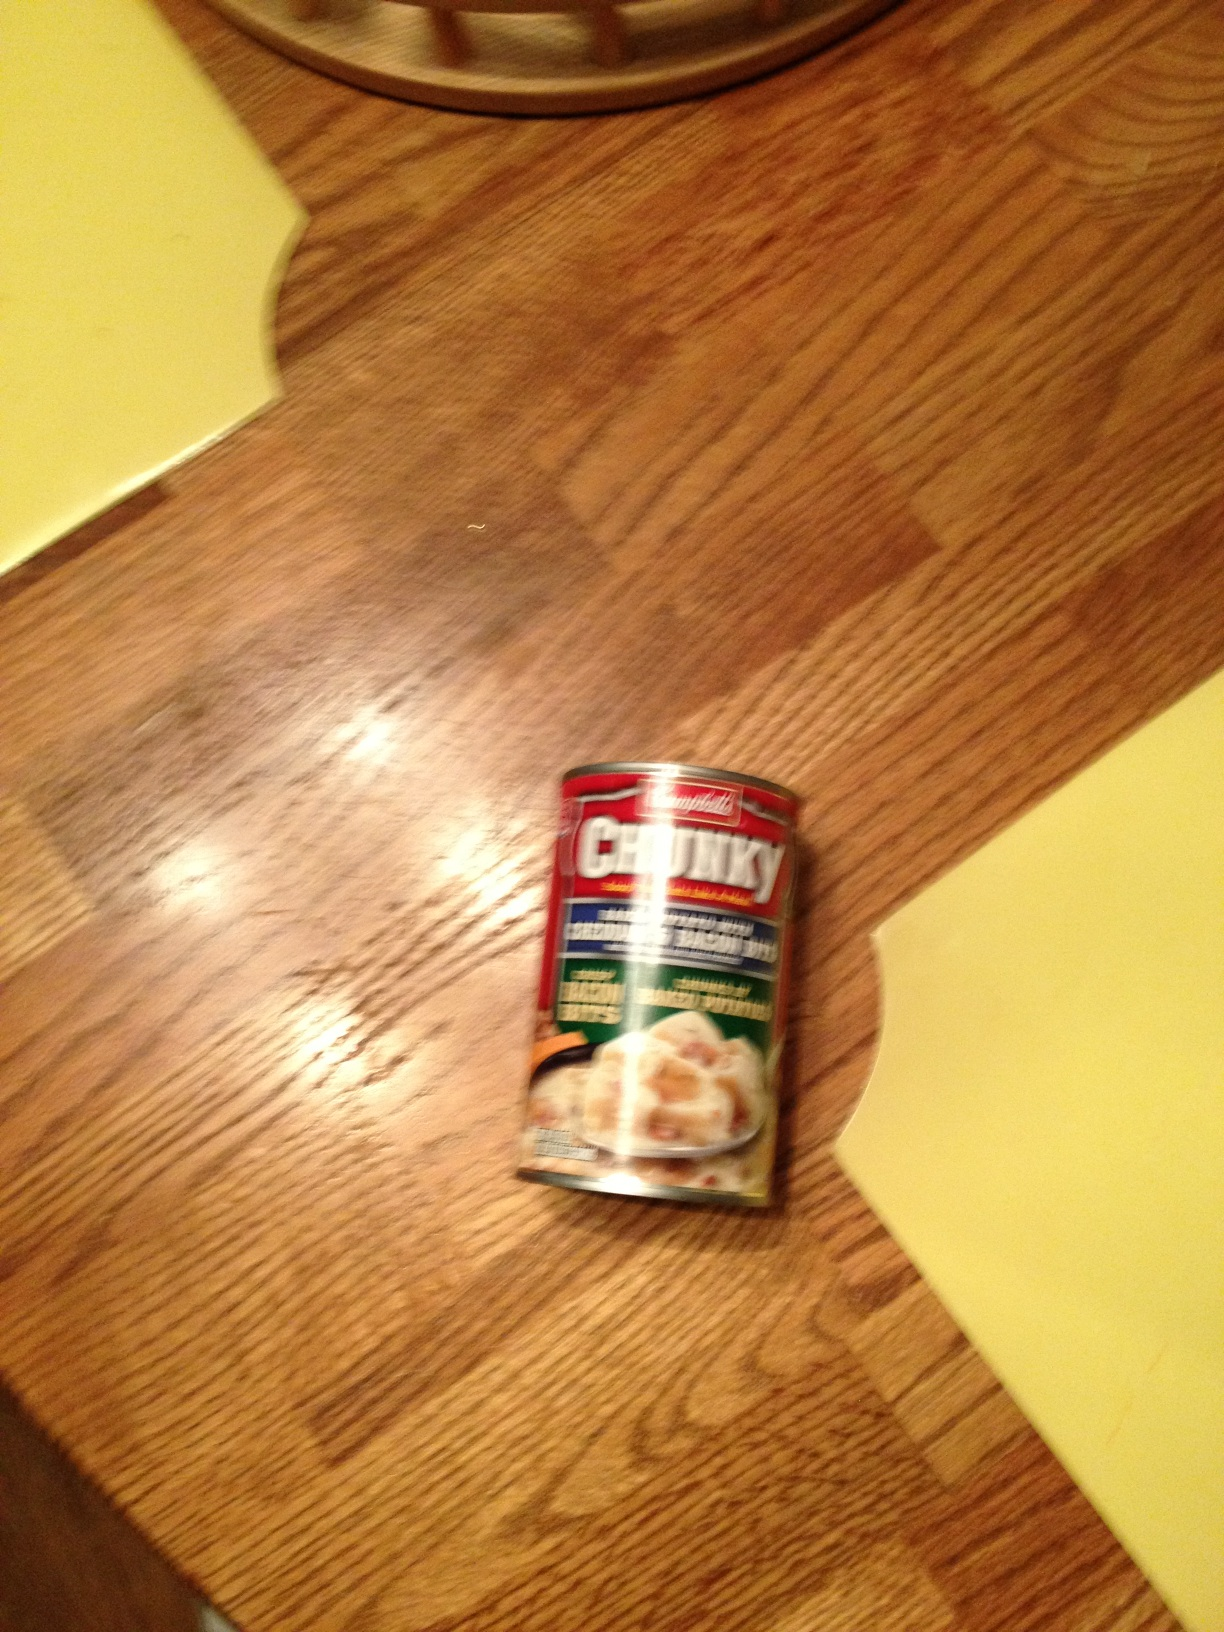What is this product? from Vizwiz soup 